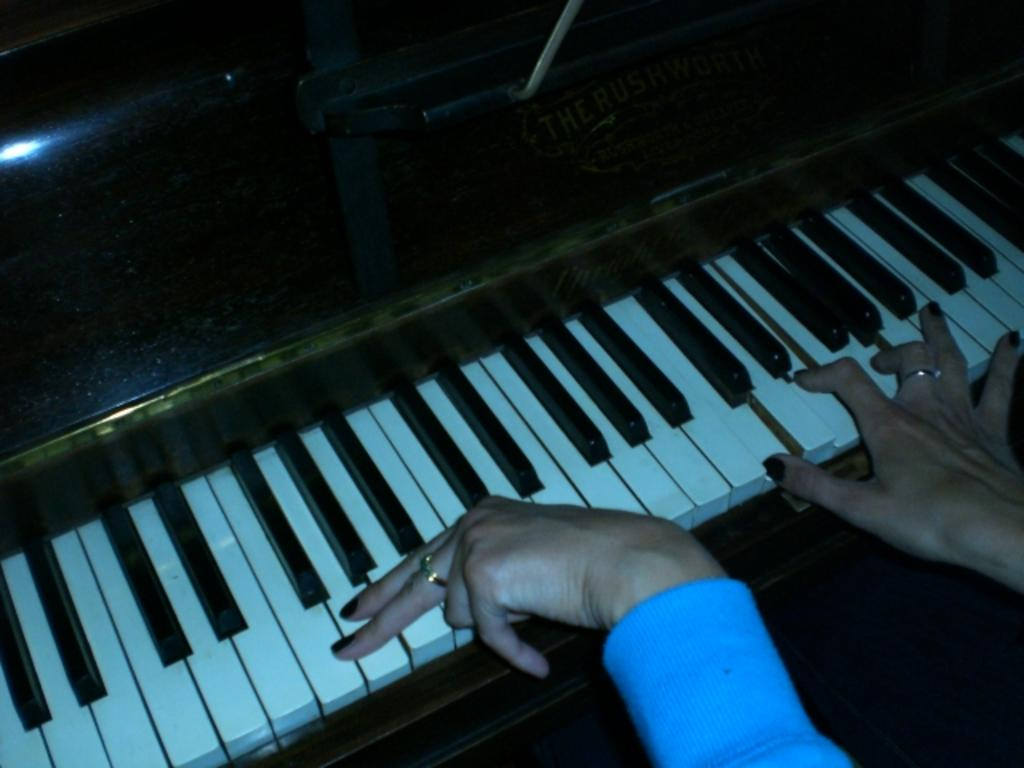What body parts are visible in the image? There are human hands in the image. What activity are the hands engaged in? The hands are playing a musical keyboard. What type of jam is being served on the flag in the image? There is no jam or flag present in the image; it only features human hands playing a musical keyboard. 